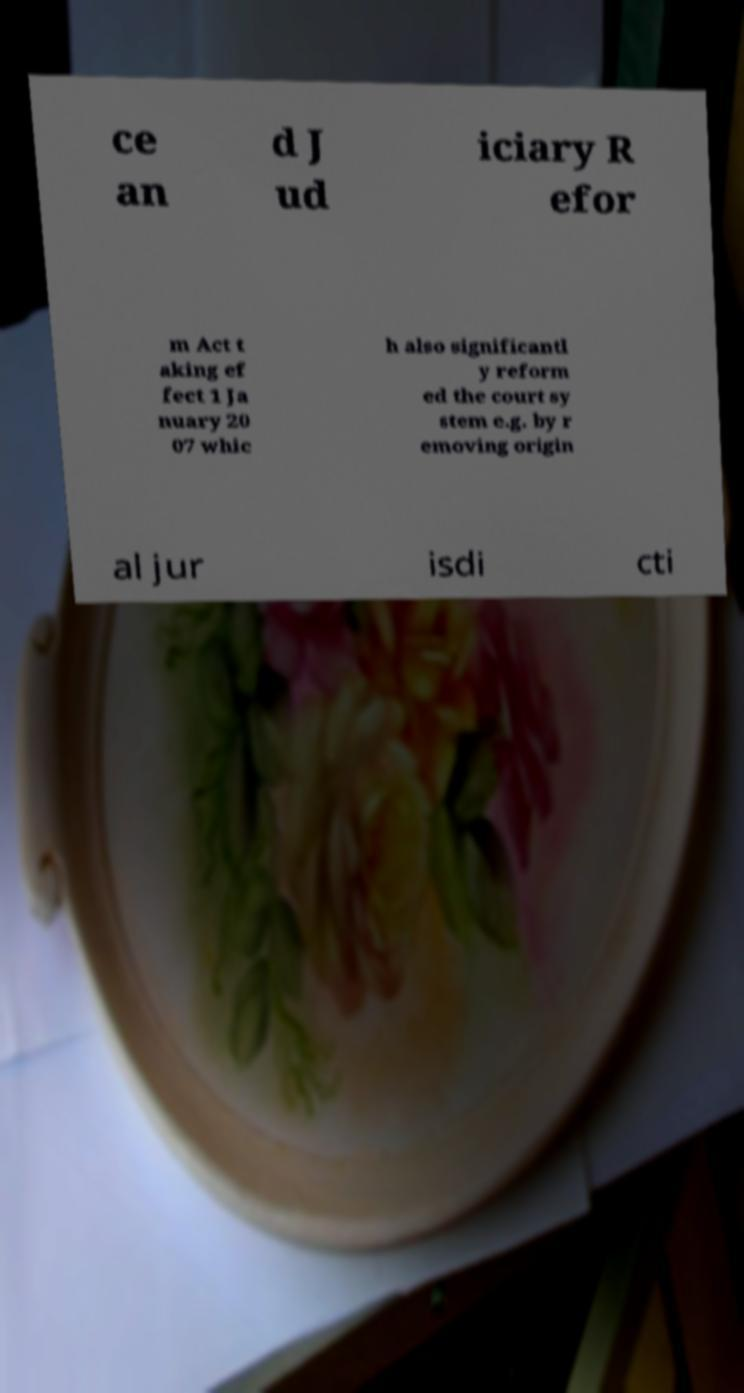Can you read and provide the text displayed in the image?This photo seems to have some interesting text. Can you extract and type it out for me? ce an d J ud iciary R efor m Act t aking ef fect 1 Ja nuary 20 07 whic h also significantl y reform ed the court sy stem e.g. by r emoving origin al jur isdi cti 